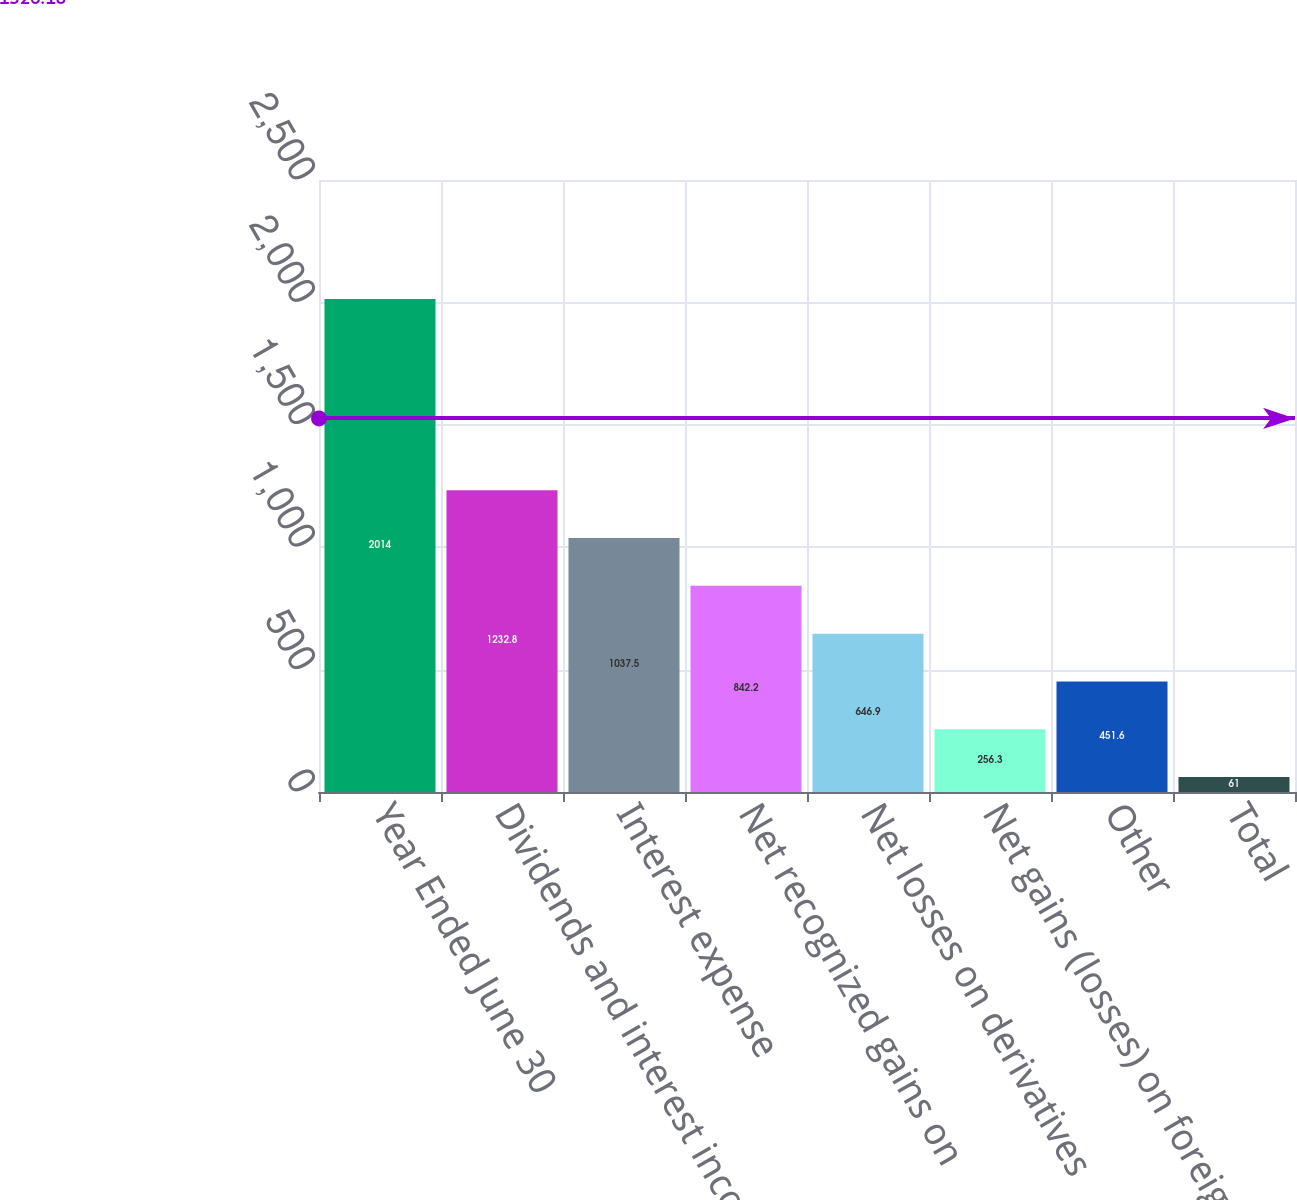Convert chart. <chart><loc_0><loc_0><loc_500><loc_500><bar_chart><fcel>Year Ended June 30<fcel>Dividends and interest income<fcel>Interest expense<fcel>Net recognized gains on<fcel>Net losses on derivatives<fcel>Net gains (losses) on foreign<fcel>Other<fcel>Total<nl><fcel>2014<fcel>1232.8<fcel>1037.5<fcel>842.2<fcel>646.9<fcel>256.3<fcel>451.6<fcel>61<nl></chart> 